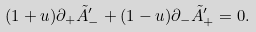Convert formula to latex. <formula><loc_0><loc_0><loc_500><loc_500>( 1 + u ) \partial _ { + } \tilde { A } ^ { \prime } _ { - } + ( 1 - u ) \partial _ { - } \tilde { A } ^ { \prime } _ { + } = 0 .</formula> 